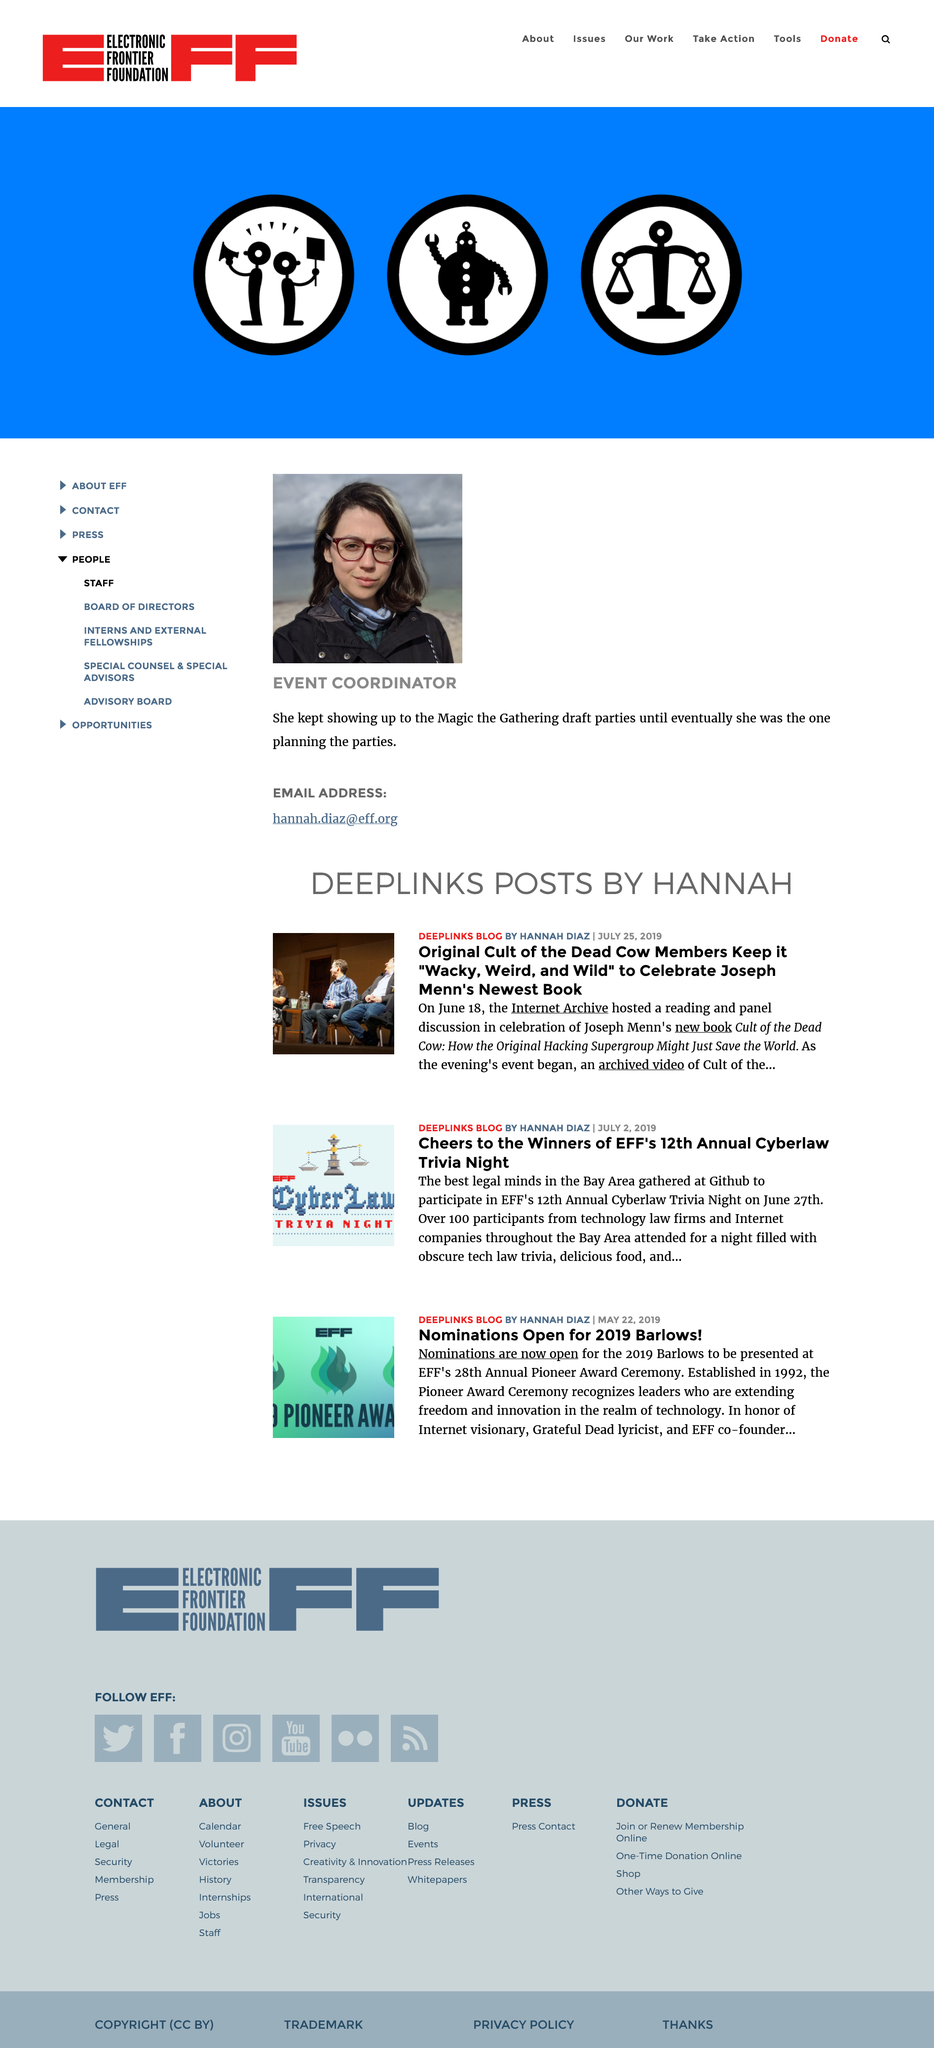Identify some key points in this picture. All three of these posts were written by Hannah Diaz. Nominations are currently being accepted for the 2019 Barlows. On June 18th, the Internet Archive hosted a reading and panel discussion in celebration of Joseph Menn's new book. 